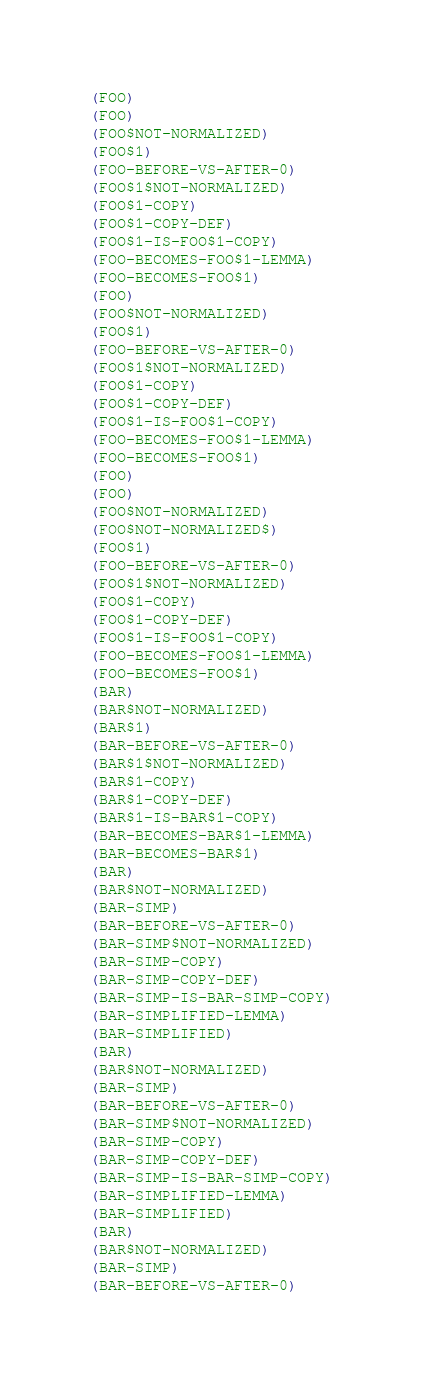<code> <loc_0><loc_0><loc_500><loc_500><_Lisp_>(FOO)
(FOO)
(FOO$NOT-NORMALIZED)
(FOO$1)
(FOO-BEFORE-VS-AFTER-0)
(FOO$1$NOT-NORMALIZED)
(FOO$1-COPY)
(FOO$1-COPY-DEF)
(FOO$1-IS-FOO$1-COPY)
(FOO-BECOMES-FOO$1-LEMMA)
(FOO-BECOMES-FOO$1)
(FOO)
(FOO$NOT-NORMALIZED)
(FOO$1)
(FOO-BEFORE-VS-AFTER-0)
(FOO$1$NOT-NORMALIZED)
(FOO$1-COPY)
(FOO$1-COPY-DEF)
(FOO$1-IS-FOO$1-COPY)
(FOO-BECOMES-FOO$1-LEMMA)
(FOO-BECOMES-FOO$1)
(FOO)
(FOO)
(FOO$NOT-NORMALIZED)
(FOO$NOT-NORMALIZED$)
(FOO$1)
(FOO-BEFORE-VS-AFTER-0)
(FOO$1$NOT-NORMALIZED)
(FOO$1-COPY)
(FOO$1-COPY-DEF)
(FOO$1-IS-FOO$1-COPY)
(FOO-BECOMES-FOO$1-LEMMA)
(FOO-BECOMES-FOO$1)
(BAR)
(BAR$NOT-NORMALIZED)
(BAR$1)
(BAR-BEFORE-VS-AFTER-0)
(BAR$1$NOT-NORMALIZED)
(BAR$1-COPY)
(BAR$1-COPY-DEF)
(BAR$1-IS-BAR$1-COPY)
(BAR-BECOMES-BAR$1-LEMMA)
(BAR-BECOMES-BAR$1)
(BAR)
(BAR$NOT-NORMALIZED)
(BAR-SIMP)
(BAR-BEFORE-VS-AFTER-0)
(BAR-SIMP$NOT-NORMALIZED)
(BAR-SIMP-COPY)
(BAR-SIMP-COPY-DEF)
(BAR-SIMP-IS-BAR-SIMP-COPY)
(BAR-SIMPLIFIED-LEMMA)
(BAR-SIMPLIFIED)
(BAR)
(BAR$NOT-NORMALIZED)
(BAR-SIMP)
(BAR-BEFORE-VS-AFTER-0)
(BAR-SIMP$NOT-NORMALIZED)
(BAR-SIMP-COPY)
(BAR-SIMP-COPY-DEF)
(BAR-SIMP-IS-BAR-SIMP-COPY)
(BAR-SIMPLIFIED-LEMMA)
(BAR-SIMPLIFIED)
(BAR)
(BAR$NOT-NORMALIZED)
(BAR-SIMP)
(BAR-BEFORE-VS-AFTER-0)</code> 